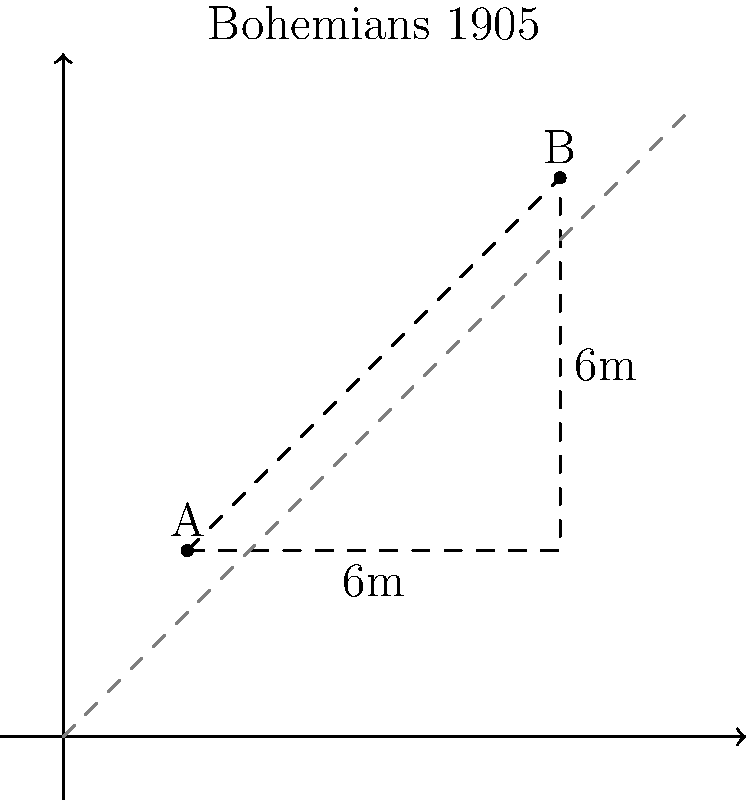During a Bohemians 1905 match, player A is at coordinates (2,3) and player B is at (8,9) on the field. Using the Pythagorean theorem, calculate the direct distance between these two players. Round your answer to the nearest tenth of a meter. Let's approach this step-by-step:

1) The Pythagorean theorem states that in a right triangle, $a^2 + b^2 = c^2$, where c is the hypotenuse (the longest side, opposite the right angle).

2) In our case, we can form a right triangle by drawing a horizontal line from A to directly below B, and a vertical line up to B.

3) The horizontal distance (let's call it x) is the difference in x-coordinates:
   $x = 8 - 2 = 6$ meters

4) The vertical distance (let's call it y) is the difference in y-coordinates:
   $y = 9 - 3 = 6$ meters

5) Now we can apply the Pythagorean theorem:
   $distance^2 = x^2 + y^2$
   $distance^2 = 6^2 + 6^2$
   $distance^2 = 36 + 36 = 72$

6) To get the distance, we take the square root of both sides:
   $distance = \sqrt{72}$

7) Simplify:
   $distance = 6\sqrt{2} \approx 8.4853$ meters

8) Rounding to the nearest tenth:
   $distance \approx 8.5$ meters
Answer: 8.5 meters 